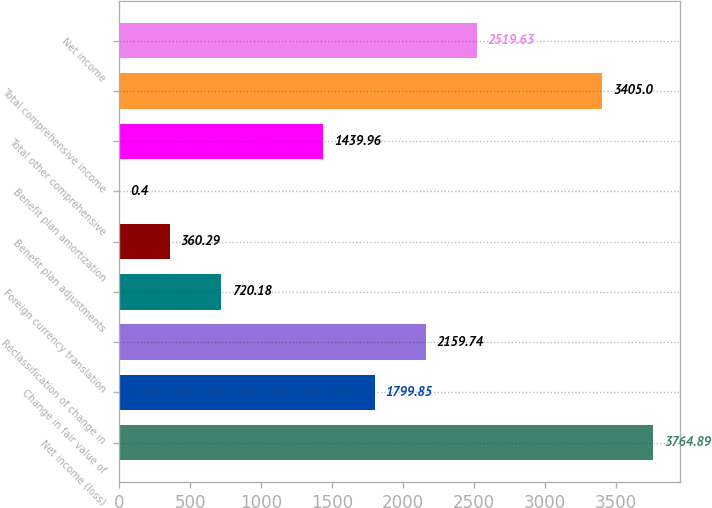<chart> <loc_0><loc_0><loc_500><loc_500><bar_chart><fcel>Net income (loss)<fcel>Change in fair value of<fcel>Reclassification of change in<fcel>Foreign currency translation<fcel>Benefit plan adjustments<fcel>Benefit plan amortization<fcel>Total other comprehensive<fcel>Total comprehensive income<fcel>Net income<nl><fcel>3764.89<fcel>1799.85<fcel>2159.74<fcel>720.18<fcel>360.29<fcel>0.4<fcel>1439.96<fcel>3405<fcel>2519.63<nl></chart> 